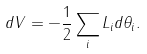Convert formula to latex. <formula><loc_0><loc_0><loc_500><loc_500>d V = - \frac { 1 } { 2 } \sum _ { i } L _ { i } d \theta _ { i } .</formula> 